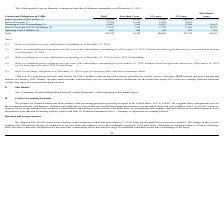According to Nordic American Tankers Limited's financial document, What does Senior Secured Credit Facility refer to? obligation to repay indebtedness outstanding as of December 31, 2019.. The document states: "(1) Refers to obligation to repay indebtedness outstanding as of December 31, 2019...." Also, What does Interest Payments refer to? estimated interest payments over the term of the indebtedness outstanding as of December 31, 2019. The document states: "(2) Refers to estimated interest payments over the term of the indebtedness outstanding as of December 31, 2019. Estimate based on applicable interest..." Also, What does Financing of 2018 Newbuildings refer to? obligation to repay indebtedness outstanding as of December 31, 2019 for three 2018 Newbuildings.. The document states: "(3) Refers to obligation to repay indebtedness outstanding as of December 31, 2019 for three 2018 Newbuildings...." Also, can you calculate: What is the average total Senior Secured Credit Facility and Interest Payments? To answer this question, I need to perform calculations using the financial data. The calculation is: (291,798 + 82,255)/2 , which equals 187026.5 (in thousands). This is based on the information: "Senior Secured Credit Facility (1)* 291,798 18,749 30,610 242,439 - Interest Payments (2) 82,255 21,690 39,624 20,941 -..." The key data points involved are: 291,798, 82,255. Also, can you calculate: What is the average total Interest Payments and Financing of 2018 Newbuildings? To answer this question, I need to perform calculations using the financial data. The calculation is: (82,255 + 119,867)/2 , which equals 101061 (in thousands). This is based on the information: "Financing of 2018 Newbuildings (3) 119,867 7,630 16,287 17,849 78,101 Interest Payments (2) 82,255 21,690 39,624 20,941 -..." The key data points involved are: 119,867, 82,255. Also, can you calculate: What is the total average Financing of 2018 Newbuildings and Interest Payments 2018 Newbuildings? To answer this question, I need to perform calculations using the financial data. The calculation is: (119,867 + 47,517)/2 , which equals 83692 (in thousands). This is based on the information: "Financing of 2018 Newbuildings (3) 119,867 7,630 16,287 17,849 78,101 Interest Payments 2018 Newbuildings (4) 47,517 7,674 13,739 11,526 14,578..." The key data points involved are: 119,867, 47,517. 